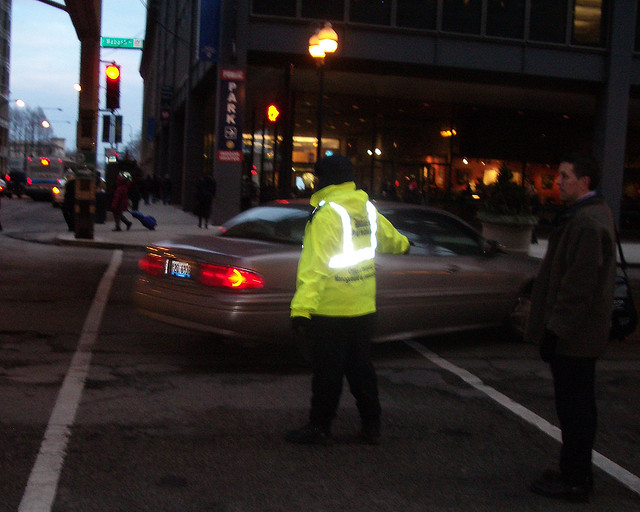<image>What is the license plate number? I don't know the exact license plate number. It appears to be illegible. What is the license plate number? It is unknown what the license plate number is. The text on the plate is illegible. 